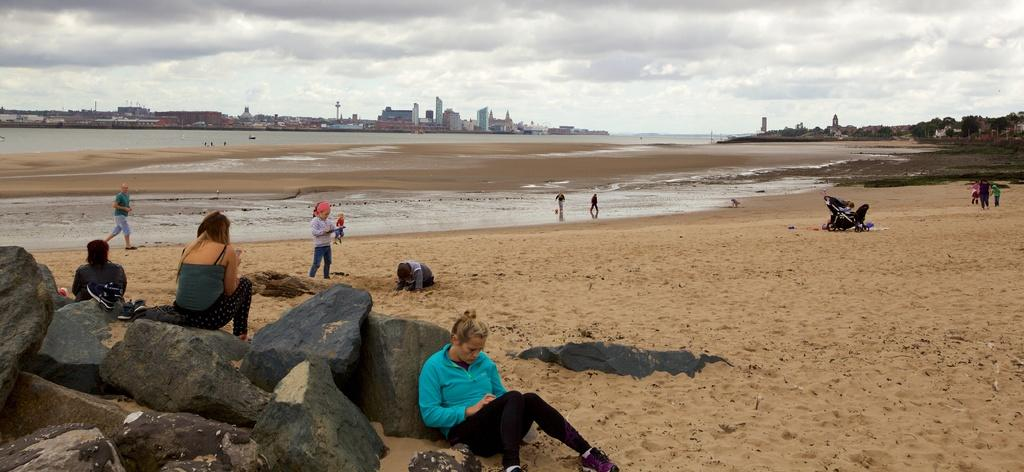What is the setting of the image? The setting of the image is a beach. What can be seen in the middle of the image? There are buildings in the middle of the image. What is located in the bottom left of the image? There are rocks in the bottom left of the image. What is visible in the sky? There are clouds in the sky. What statement does the father make about the board in the image? There is no father or board present in the image, so it is not possible to answer that question. 